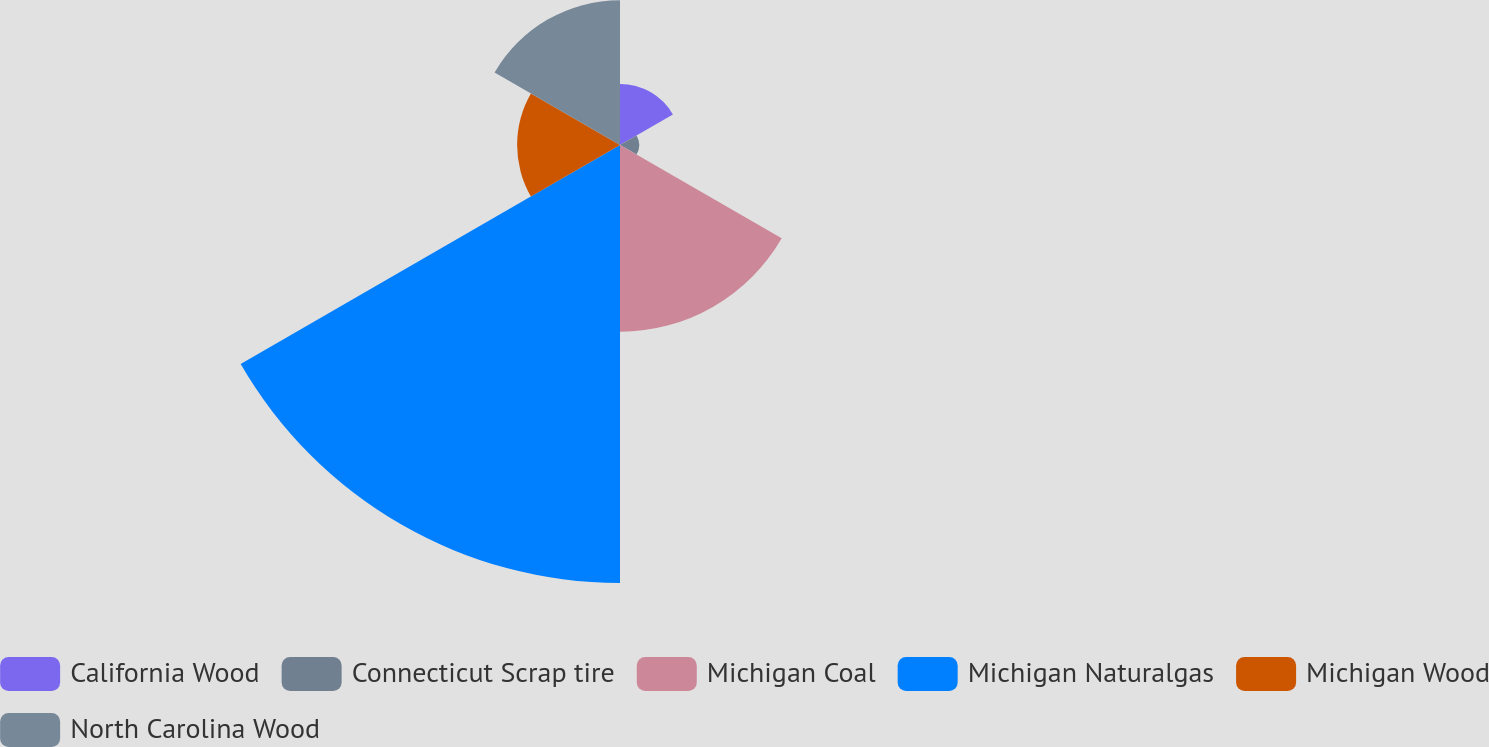Convert chart to OTSL. <chart><loc_0><loc_0><loc_500><loc_500><pie_chart><fcel>California Wood<fcel>Connecticut Scrap tire<fcel>Michigan Coal<fcel>Michigan Naturalgas<fcel>Michigan Wood<fcel>North Carolina Wood<nl><fcel>6.41%<fcel>2.01%<fcel>19.6%<fcel>45.98%<fcel>10.8%<fcel>15.2%<nl></chart> 